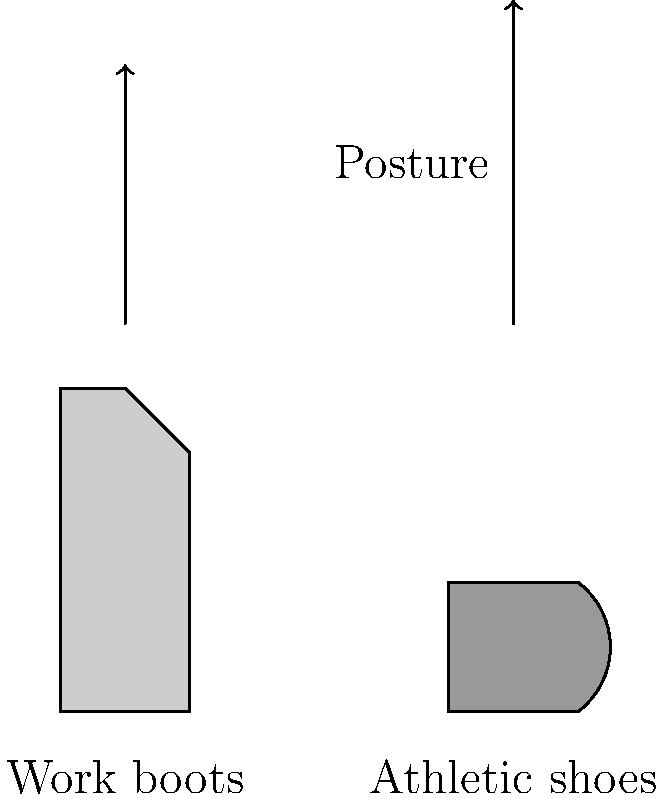As a factory worker, which type of footwear is likely to provide better support for maintaining proper body alignment and posture during long shifts on concrete floors? To answer this question, let's consider the key factors:

1. Support: Work boots typically offer more ankle support and a sturdier sole, which can help maintain proper alignment on hard surfaces.

2. Cushioning: Athletic shoes often have more cushioning, which can absorb shock but may not provide as much stability.

3. Heel height: Work boots usually have a slightly raised heel, which can help distribute weight more evenly and reduce strain on the lower back.

4. Arch support: Work boots are designed with arch support for long periods of standing, which is crucial for maintaining proper posture.

5. Durability: Work boots are built to withstand harsh conditions and provide consistent support over time.

6. Safety features: Work boots often include safety toes and slip-resistant soles, which can contribute to better stability and posture.

7. Weight distribution: The design of work boots helps distribute weight more evenly across the foot, reducing strain on specific areas.

Given these factors, work boots are more likely to provide better support for maintaining proper body alignment and posture during long shifts on concrete floors. The sturdy construction, ankle support, and design features of work boots are specifically tailored to the needs of workers who spend long hours standing on hard surfaces.
Answer: Work boots 